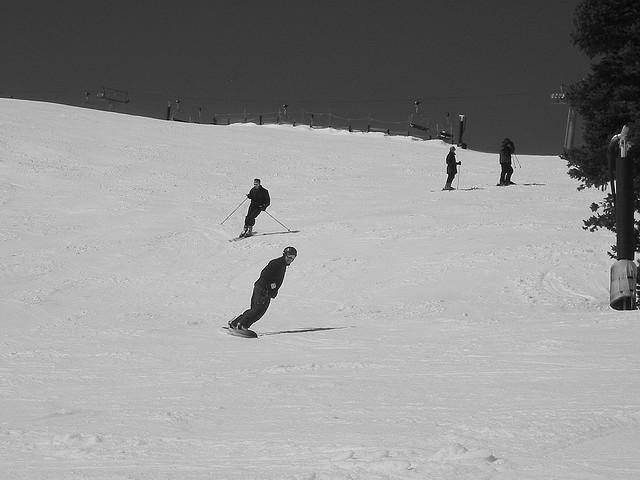How many people are skiing?
Give a very brief answer. 4. How many people can be counted in this photo?
Give a very brief answer. 4. How many people are in the photo?
Give a very brief answer. 4. How many people are snowboarding?
Give a very brief answer. 1. How many people are shown?
Give a very brief answer. 4. How many orange slices?
Give a very brief answer. 0. 